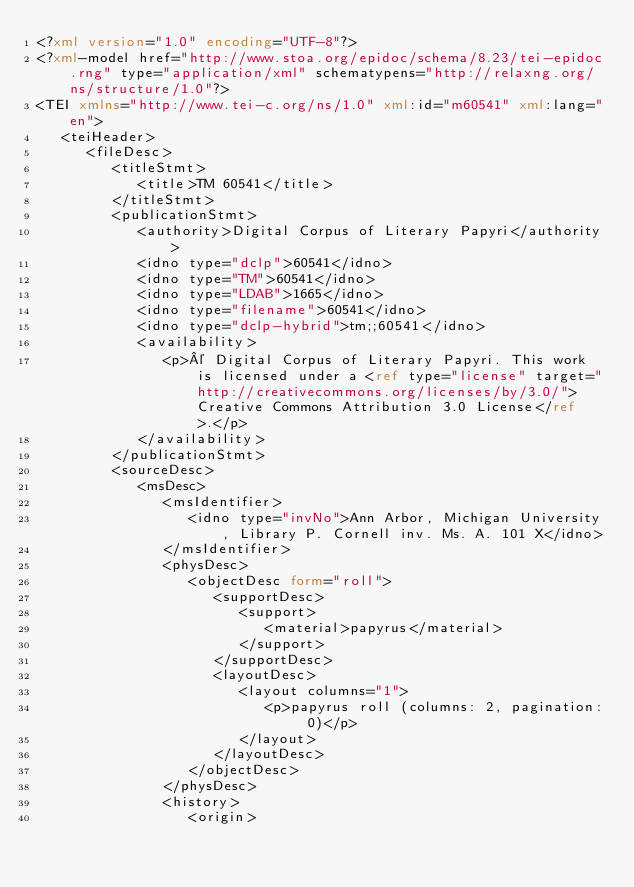<code> <loc_0><loc_0><loc_500><loc_500><_XML_><?xml version="1.0" encoding="UTF-8"?>
<?xml-model href="http://www.stoa.org/epidoc/schema/8.23/tei-epidoc.rng" type="application/xml" schematypens="http://relaxng.org/ns/structure/1.0"?>
<TEI xmlns="http://www.tei-c.org/ns/1.0" xml:id="m60541" xml:lang="en">
   <teiHeader>
      <fileDesc>
         <titleStmt>
            <title>TM 60541</title>
         </titleStmt>
         <publicationStmt>
            <authority>Digital Corpus of Literary Papyri</authority>
            <idno type="dclp">60541</idno>
            <idno type="TM">60541</idno>
            <idno type="LDAB">1665</idno>
            <idno type="filename">60541</idno>
            <idno type="dclp-hybrid">tm;;60541</idno>
            <availability>
               <p>© Digital Corpus of Literary Papyri. This work is licensed under a <ref type="license" target="http://creativecommons.org/licenses/by/3.0/">Creative Commons Attribution 3.0 License</ref>.</p>
            </availability>
         </publicationStmt>
         <sourceDesc>
            <msDesc>
               <msIdentifier>
                  <idno type="invNo">Ann Arbor, Michigan University, Library P. Cornell inv. Ms. A. 101 X</idno>
               </msIdentifier>
               <physDesc>
                  <objectDesc form="roll">
                     <supportDesc>
                        <support>
                           <material>papyrus</material>
                        </support>
                     </supportDesc>
                     <layoutDesc>
                        <layout columns="1">
                           <p>papyrus roll (columns: 2, pagination: 0)</p>
                        </layout>
                     </layoutDesc>
                  </objectDesc>
               </physDesc>
               <history>
                  <origin></code> 